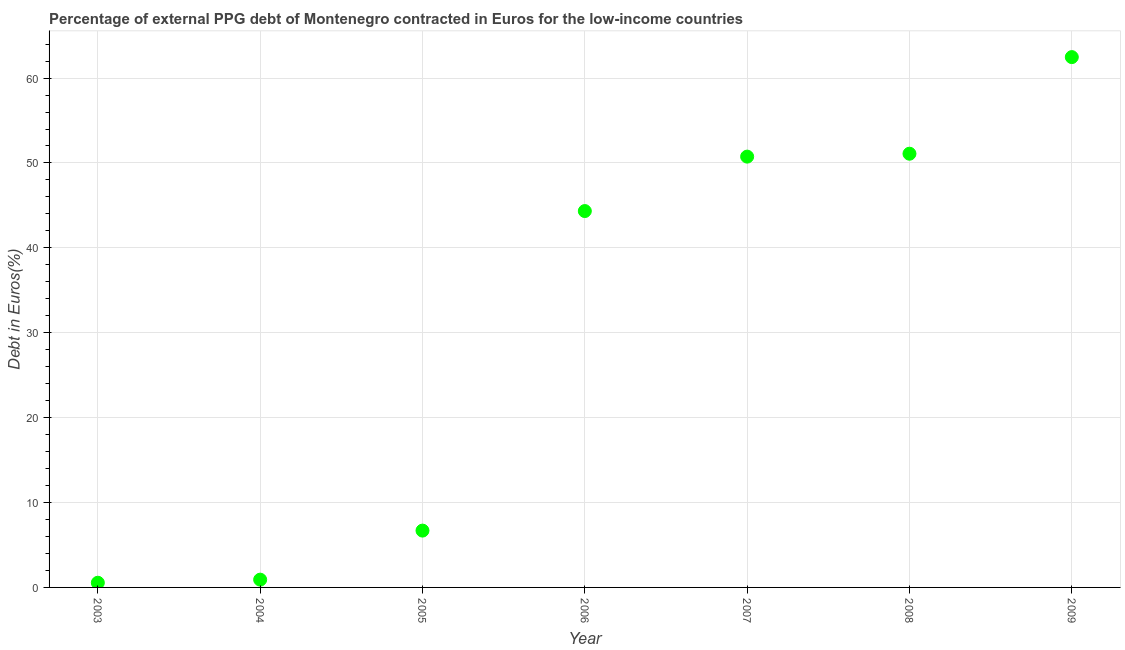What is the currency composition of ppg debt in 2009?
Provide a succinct answer. 62.47. Across all years, what is the maximum currency composition of ppg debt?
Offer a very short reply. 62.47. Across all years, what is the minimum currency composition of ppg debt?
Provide a succinct answer. 0.55. In which year was the currency composition of ppg debt maximum?
Give a very brief answer. 2009. In which year was the currency composition of ppg debt minimum?
Make the answer very short. 2003. What is the sum of the currency composition of ppg debt?
Make the answer very short. 216.81. What is the difference between the currency composition of ppg debt in 2003 and 2008?
Your answer should be compact. -50.54. What is the average currency composition of ppg debt per year?
Your answer should be very brief. 30.97. What is the median currency composition of ppg debt?
Your answer should be very brief. 44.34. In how many years, is the currency composition of ppg debt greater than 38 %?
Ensure brevity in your answer.  4. Do a majority of the years between 2005 and 2004 (inclusive) have currency composition of ppg debt greater than 56 %?
Your response must be concise. No. What is the ratio of the currency composition of ppg debt in 2003 to that in 2004?
Provide a succinct answer. 0.6. Is the currency composition of ppg debt in 2003 less than that in 2009?
Provide a succinct answer. Yes. Is the difference between the currency composition of ppg debt in 2004 and 2008 greater than the difference between any two years?
Provide a succinct answer. No. What is the difference between the highest and the second highest currency composition of ppg debt?
Provide a succinct answer. 11.38. Is the sum of the currency composition of ppg debt in 2003 and 2007 greater than the maximum currency composition of ppg debt across all years?
Ensure brevity in your answer.  No. What is the difference between the highest and the lowest currency composition of ppg debt?
Provide a succinct answer. 61.92. Does the currency composition of ppg debt monotonically increase over the years?
Offer a terse response. Yes. How many dotlines are there?
Your answer should be compact. 1. How many years are there in the graph?
Make the answer very short. 7. What is the title of the graph?
Make the answer very short. Percentage of external PPG debt of Montenegro contracted in Euros for the low-income countries. What is the label or title of the Y-axis?
Keep it short and to the point. Debt in Euros(%). What is the Debt in Euros(%) in 2003?
Your answer should be compact. 0.55. What is the Debt in Euros(%) in 2004?
Keep it short and to the point. 0.92. What is the Debt in Euros(%) in 2005?
Offer a terse response. 6.69. What is the Debt in Euros(%) in 2006?
Provide a short and direct response. 44.34. What is the Debt in Euros(%) in 2007?
Provide a succinct answer. 50.75. What is the Debt in Euros(%) in 2008?
Offer a very short reply. 51.09. What is the Debt in Euros(%) in 2009?
Your answer should be compact. 62.47. What is the difference between the Debt in Euros(%) in 2003 and 2004?
Your response must be concise. -0.36. What is the difference between the Debt in Euros(%) in 2003 and 2005?
Keep it short and to the point. -6.14. What is the difference between the Debt in Euros(%) in 2003 and 2006?
Your answer should be very brief. -43.78. What is the difference between the Debt in Euros(%) in 2003 and 2007?
Your answer should be compact. -50.2. What is the difference between the Debt in Euros(%) in 2003 and 2008?
Make the answer very short. -50.54. What is the difference between the Debt in Euros(%) in 2003 and 2009?
Provide a succinct answer. -61.92. What is the difference between the Debt in Euros(%) in 2004 and 2005?
Your answer should be very brief. -5.78. What is the difference between the Debt in Euros(%) in 2004 and 2006?
Your answer should be compact. -43.42. What is the difference between the Debt in Euros(%) in 2004 and 2007?
Provide a succinct answer. -49.83. What is the difference between the Debt in Euros(%) in 2004 and 2008?
Ensure brevity in your answer.  -50.17. What is the difference between the Debt in Euros(%) in 2004 and 2009?
Make the answer very short. -61.55. What is the difference between the Debt in Euros(%) in 2005 and 2006?
Ensure brevity in your answer.  -37.64. What is the difference between the Debt in Euros(%) in 2005 and 2007?
Ensure brevity in your answer.  -44.05. What is the difference between the Debt in Euros(%) in 2005 and 2008?
Provide a succinct answer. -44.4. What is the difference between the Debt in Euros(%) in 2005 and 2009?
Your response must be concise. -55.78. What is the difference between the Debt in Euros(%) in 2006 and 2007?
Ensure brevity in your answer.  -6.41. What is the difference between the Debt in Euros(%) in 2006 and 2008?
Your answer should be very brief. -6.76. What is the difference between the Debt in Euros(%) in 2006 and 2009?
Offer a very short reply. -18.14. What is the difference between the Debt in Euros(%) in 2007 and 2008?
Ensure brevity in your answer.  -0.34. What is the difference between the Debt in Euros(%) in 2007 and 2009?
Ensure brevity in your answer.  -11.72. What is the difference between the Debt in Euros(%) in 2008 and 2009?
Ensure brevity in your answer.  -11.38. What is the ratio of the Debt in Euros(%) in 2003 to that in 2004?
Offer a very short reply. 0.6. What is the ratio of the Debt in Euros(%) in 2003 to that in 2005?
Provide a succinct answer. 0.08. What is the ratio of the Debt in Euros(%) in 2003 to that in 2006?
Provide a short and direct response. 0.01. What is the ratio of the Debt in Euros(%) in 2003 to that in 2007?
Offer a terse response. 0.01. What is the ratio of the Debt in Euros(%) in 2003 to that in 2008?
Make the answer very short. 0.01. What is the ratio of the Debt in Euros(%) in 2003 to that in 2009?
Keep it short and to the point. 0.01. What is the ratio of the Debt in Euros(%) in 2004 to that in 2005?
Your answer should be very brief. 0.14. What is the ratio of the Debt in Euros(%) in 2004 to that in 2006?
Ensure brevity in your answer.  0.02. What is the ratio of the Debt in Euros(%) in 2004 to that in 2007?
Give a very brief answer. 0.02. What is the ratio of the Debt in Euros(%) in 2004 to that in 2008?
Your response must be concise. 0.02. What is the ratio of the Debt in Euros(%) in 2004 to that in 2009?
Provide a short and direct response. 0.01. What is the ratio of the Debt in Euros(%) in 2005 to that in 2006?
Give a very brief answer. 0.15. What is the ratio of the Debt in Euros(%) in 2005 to that in 2007?
Your answer should be very brief. 0.13. What is the ratio of the Debt in Euros(%) in 2005 to that in 2008?
Make the answer very short. 0.13. What is the ratio of the Debt in Euros(%) in 2005 to that in 2009?
Ensure brevity in your answer.  0.11. What is the ratio of the Debt in Euros(%) in 2006 to that in 2007?
Offer a very short reply. 0.87. What is the ratio of the Debt in Euros(%) in 2006 to that in 2008?
Your answer should be very brief. 0.87. What is the ratio of the Debt in Euros(%) in 2006 to that in 2009?
Your answer should be compact. 0.71. What is the ratio of the Debt in Euros(%) in 2007 to that in 2008?
Your answer should be compact. 0.99. What is the ratio of the Debt in Euros(%) in 2007 to that in 2009?
Ensure brevity in your answer.  0.81. What is the ratio of the Debt in Euros(%) in 2008 to that in 2009?
Provide a short and direct response. 0.82. 